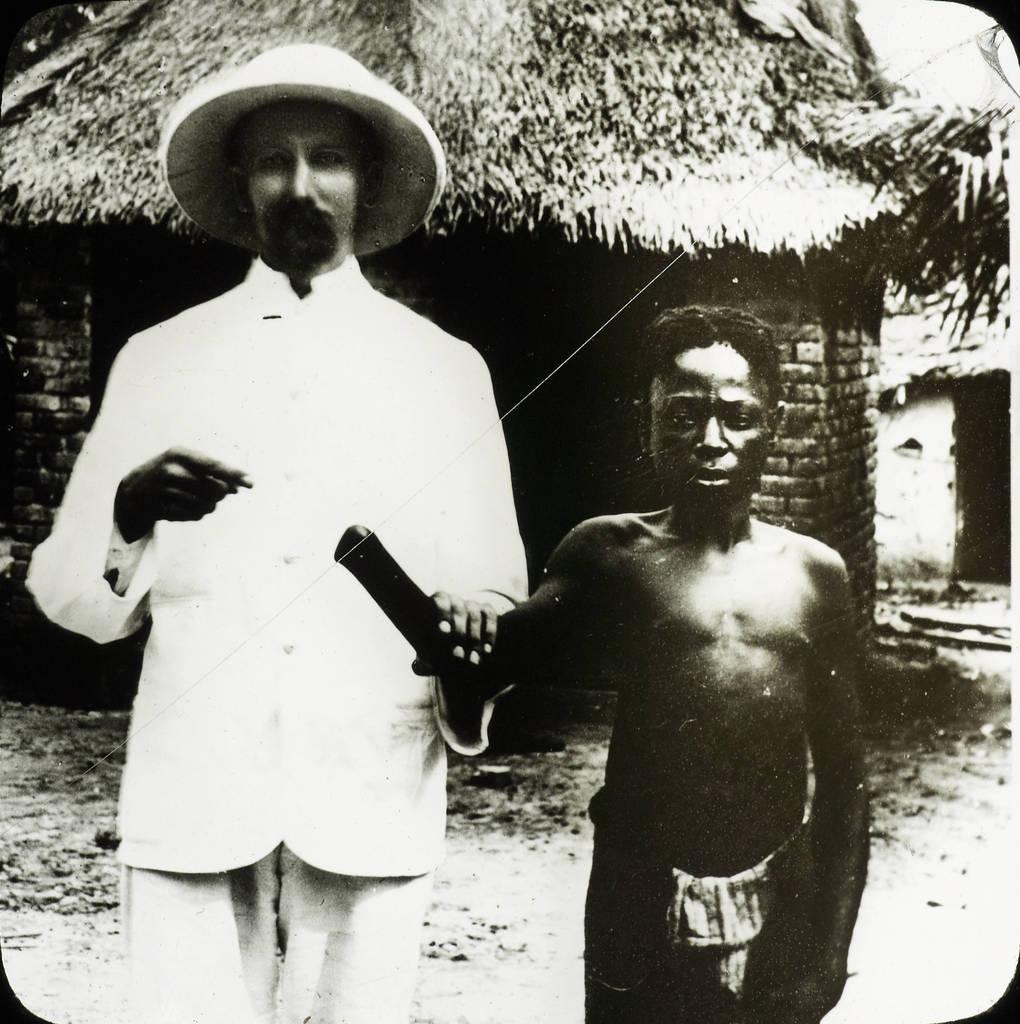How many people are in the image? There are two men in the image. What is the man on the left side wearing? The man on the left side is wearing a cap. What can be seen in the background of the image? There are hurts visible behind the men. What is the color scheme of the image? The image is in black and white. What type of soda is the man on the right side holding in the image? There is no soda present in the image; it is in black and white and features two men and hurts in the background. 